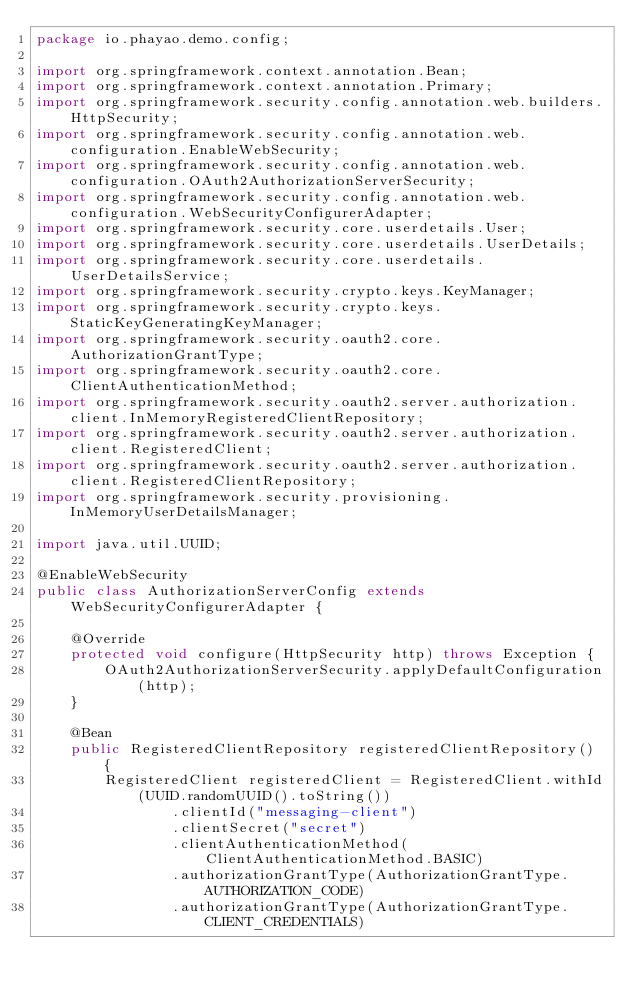Convert code to text. <code><loc_0><loc_0><loc_500><loc_500><_Java_>package io.phayao.demo.config;

import org.springframework.context.annotation.Bean;
import org.springframework.context.annotation.Primary;
import org.springframework.security.config.annotation.web.builders.HttpSecurity;
import org.springframework.security.config.annotation.web.configuration.EnableWebSecurity;
import org.springframework.security.config.annotation.web.configuration.OAuth2AuthorizationServerSecurity;
import org.springframework.security.config.annotation.web.configuration.WebSecurityConfigurerAdapter;
import org.springframework.security.core.userdetails.User;
import org.springframework.security.core.userdetails.UserDetails;
import org.springframework.security.core.userdetails.UserDetailsService;
import org.springframework.security.crypto.keys.KeyManager;
import org.springframework.security.crypto.keys.StaticKeyGeneratingKeyManager;
import org.springframework.security.oauth2.core.AuthorizationGrantType;
import org.springframework.security.oauth2.core.ClientAuthenticationMethod;
import org.springframework.security.oauth2.server.authorization.client.InMemoryRegisteredClientRepository;
import org.springframework.security.oauth2.server.authorization.client.RegisteredClient;
import org.springframework.security.oauth2.server.authorization.client.RegisteredClientRepository;
import org.springframework.security.provisioning.InMemoryUserDetailsManager;

import java.util.UUID;

@EnableWebSecurity
public class AuthorizationServerConfig extends WebSecurityConfigurerAdapter {

    @Override
    protected void configure(HttpSecurity http) throws Exception {
        OAuth2AuthorizationServerSecurity.applyDefaultConfiguration(http);
    }

    @Bean
    public RegisteredClientRepository registeredClientRepository() {
        RegisteredClient registeredClient = RegisteredClient.withId(UUID.randomUUID().toString())
                .clientId("messaging-client")
                .clientSecret("secret")
                .clientAuthenticationMethod(ClientAuthenticationMethod.BASIC)
                .authorizationGrantType(AuthorizationGrantType.AUTHORIZATION_CODE)
                .authorizationGrantType(AuthorizationGrantType.CLIENT_CREDENTIALS)</code> 